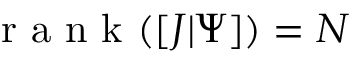<formula> <loc_0><loc_0><loc_500><loc_500>r a n k ( [ J | \Psi ] ) = N</formula> 